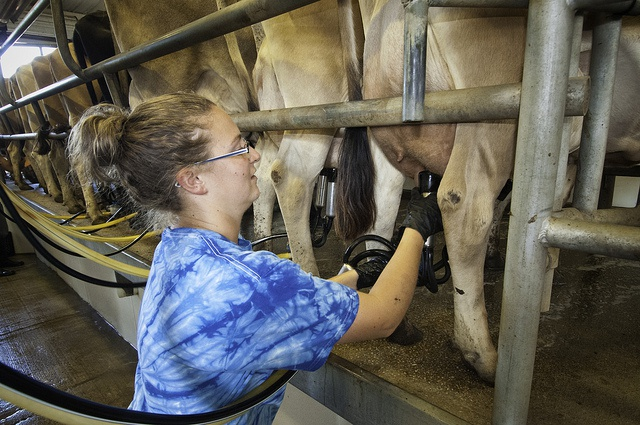Describe the objects in this image and their specific colors. I can see people in black, gray, lightblue, and blue tones, cow in black, tan, and gray tones, cow in black, tan, olive, and beige tones, cow in black, olive, gray, and tan tones, and cow in black and gray tones in this image. 